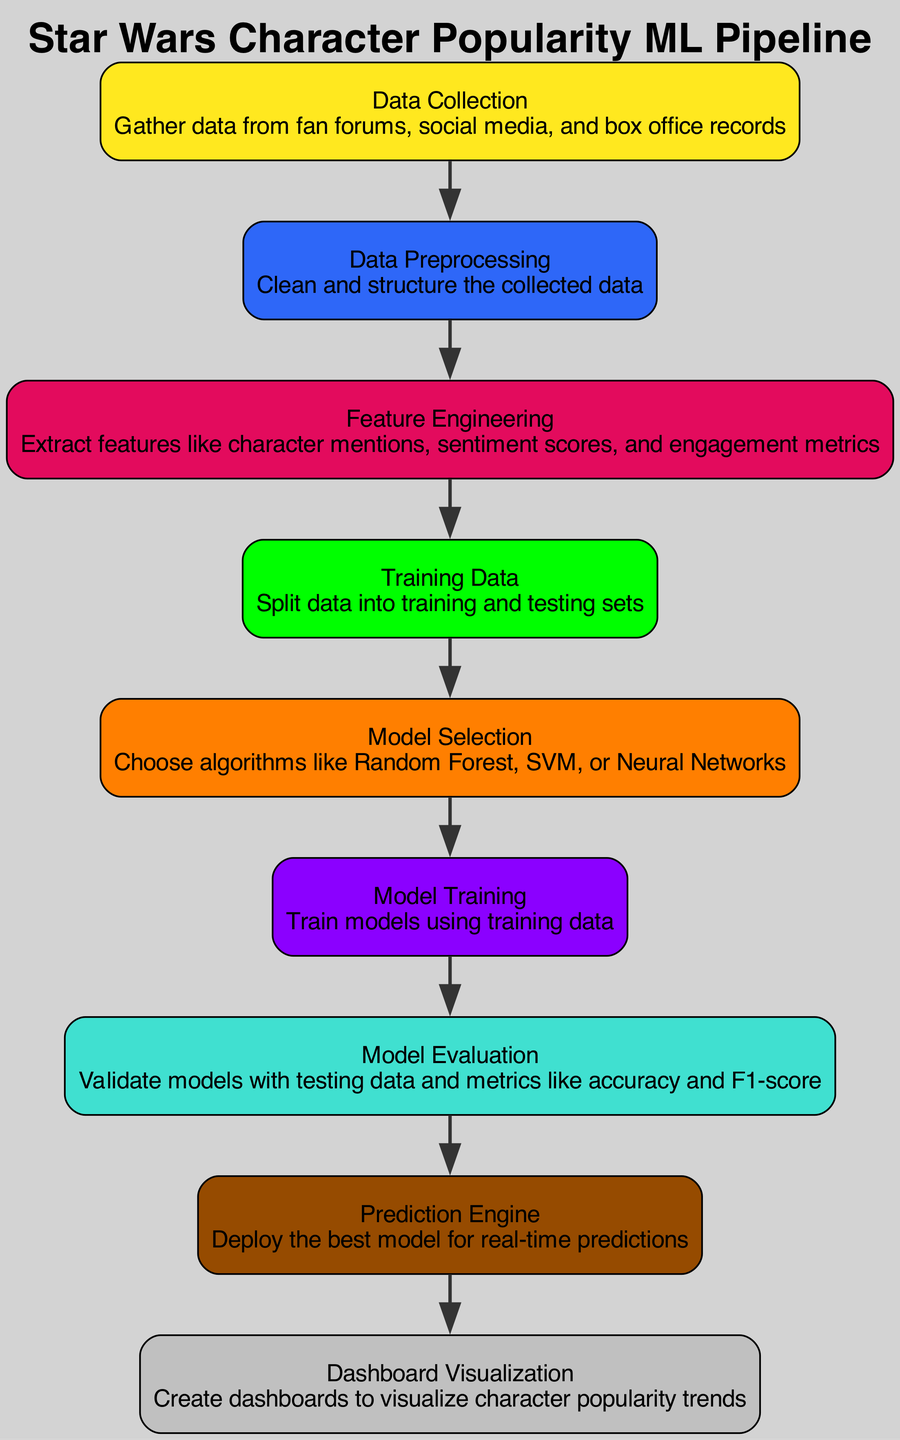What is the first step in the ML pipeline? The first step is labeled "Data Collection" and involves gathering data from fan forums, social media, and box office records.
Answer: Data Collection How many nodes are present in the diagram? Counting the nodes in the diagram, there are a total of nine nodes depicted.
Answer: 9 What connects "Model Training" to "Model Evaluation"? The edge connects the nodes "Model Training" and "Model Evaluation," indicating that the output of model training is input into model evaluation for validation purposes.
Answer: Model Training to Model Evaluation Which algorithm types are suggested for "Model Selection"? The "Model Selection" node indicates algorithms such as Random Forest, SVM, or Neural Networks for consideration in the model selection process.
Answer: Random Forest, SVM, or Neural Networks What does the "Prediction Engine" node represent? The "Prediction Engine" node represents the deployment of the best model, enabling real-time predictions based on fan engagement trends.
Answer: Deploy best model for real-time predictions Which node follows "Feature Engineering"? After "Feature Engineering," the next node indicated is "Training Data," showing that feature extraction is a prerequisite for splitting the data into training and testing sets.
Answer: Training Data What metric is used in "Model Evaluation"? The "Model Evaluation" node mentions metrics like accuracy and F1-score to assess model performance after validation.
Answer: Accuracy and F1-score What is the purpose of the "Dashboard Visualization" node? The "Dashboard Visualization" node is designed to create visual dashboards that display character popularity trends, aiding in the analysis of fan engagement.
Answer: Visualize character popularity trends Which phase involves cleaning and structuring the collected data? The "Data Preprocessing" phase is responsible for cleaning and structuring the data collected from various sources before further analysis and modeling.
Answer: Data Preprocessing 